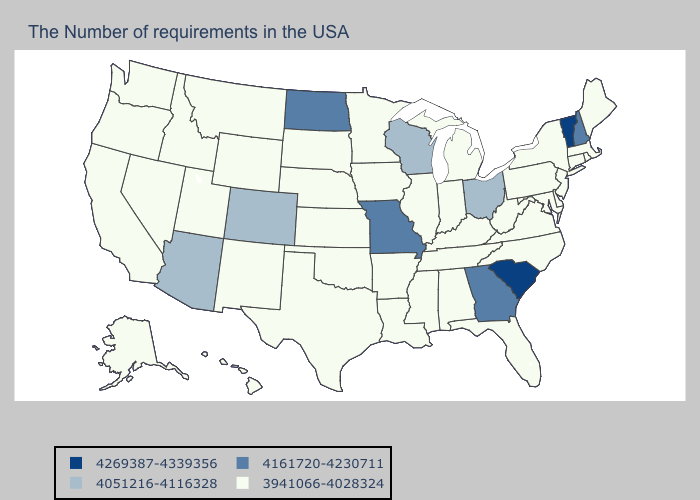Does Georgia have the lowest value in the South?
Write a very short answer. No. How many symbols are there in the legend?
Be succinct. 4. Name the states that have a value in the range 3941066-4028324?
Be succinct. Maine, Massachusetts, Rhode Island, Connecticut, New York, New Jersey, Delaware, Maryland, Pennsylvania, Virginia, North Carolina, West Virginia, Florida, Michigan, Kentucky, Indiana, Alabama, Tennessee, Illinois, Mississippi, Louisiana, Arkansas, Minnesota, Iowa, Kansas, Nebraska, Oklahoma, Texas, South Dakota, Wyoming, New Mexico, Utah, Montana, Idaho, Nevada, California, Washington, Oregon, Alaska, Hawaii. What is the highest value in the South ?
Be succinct. 4269387-4339356. Name the states that have a value in the range 4051216-4116328?
Be succinct. Ohio, Wisconsin, Colorado, Arizona. Which states have the lowest value in the MidWest?
Concise answer only. Michigan, Indiana, Illinois, Minnesota, Iowa, Kansas, Nebraska, South Dakota. What is the highest value in the MidWest ?
Keep it brief. 4161720-4230711. Among the states that border Illinois , which have the highest value?
Keep it brief. Missouri. Name the states that have a value in the range 4051216-4116328?
Answer briefly. Ohio, Wisconsin, Colorado, Arizona. Which states have the lowest value in the USA?
Short answer required. Maine, Massachusetts, Rhode Island, Connecticut, New York, New Jersey, Delaware, Maryland, Pennsylvania, Virginia, North Carolina, West Virginia, Florida, Michigan, Kentucky, Indiana, Alabama, Tennessee, Illinois, Mississippi, Louisiana, Arkansas, Minnesota, Iowa, Kansas, Nebraska, Oklahoma, Texas, South Dakota, Wyoming, New Mexico, Utah, Montana, Idaho, Nevada, California, Washington, Oregon, Alaska, Hawaii. Does Massachusetts have the highest value in the USA?
Short answer required. No. What is the lowest value in the South?
Answer briefly. 3941066-4028324. What is the value of New Hampshire?
Write a very short answer. 4161720-4230711. What is the highest value in the South ?
Quick response, please. 4269387-4339356. What is the value of Minnesota?
Give a very brief answer. 3941066-4028324. 